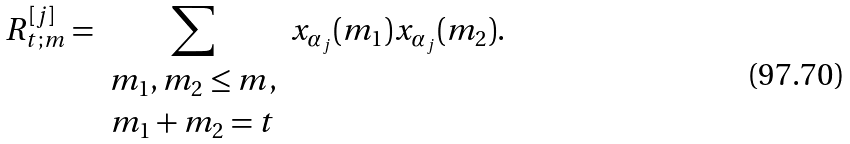Convert formula to latex. <formula><loc_0><loc_0><loc_500><loc_500>R _ { t ; m } ^ { [ j ] } = \sum _ { \begin{array} { c } m _ { 1 } , m _ { 2 } \leq m , \\ m _ { 1 } + m _ { 2 } = t \end{array} } x _ { \alpha _ { j } } ( m _ { 1 } ) x _ { \alpha _ { j } } ( m _ { 2 } ) .</formula> 